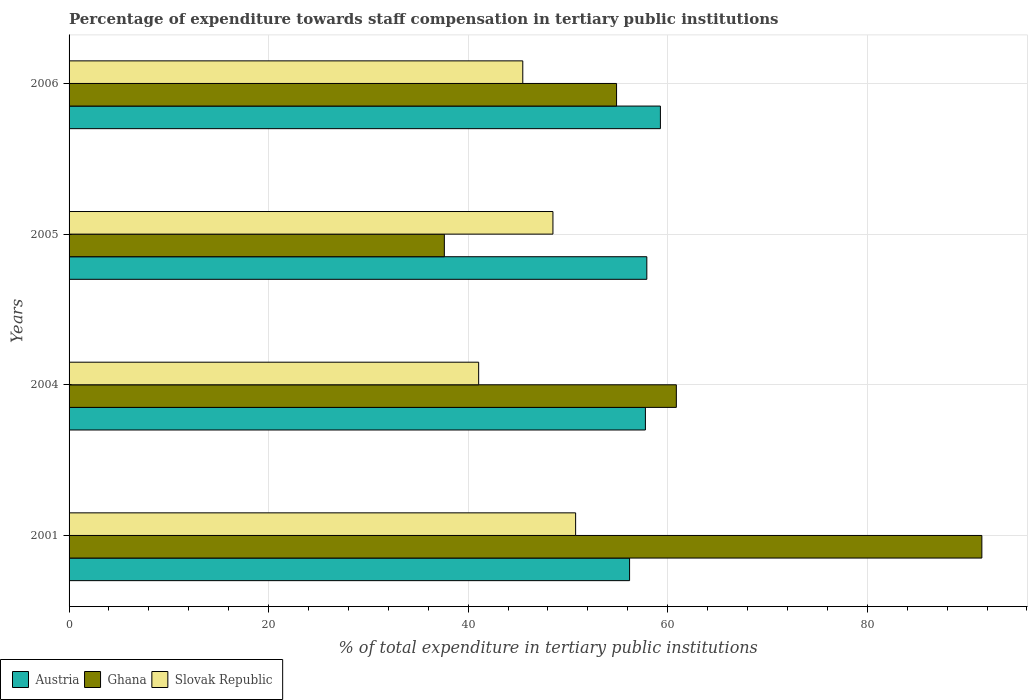Are the number of bars on each tick of the Y-axis equal?
Provide a succinct answer. Yes. How many bars are there on the 4th tick from the bottom?
Your answer should be very brief. 3. What is the label of the 4th group of bars from the top?
Your answer should be compact. 2001. In how many cases, is the number of bars for a given year not equal to the number of legend labels?
Keep it short and to the point. 0. What is the percentage of expenditure towards staff compensation in Slovak Republic in 2006?
Offer a very short reply. 45.47. Across all years, what is the maximum percentage of expenditure towards staff compensation in Slovak Republic?
Your answer should be very brief. 50.77. Across all years, what is the minimum percentage of expenditure towards staff compensation in Slovak Republic?
Offer a very short reply. 41.05. What is the total percentage of expenditure towards staff compensation in Austria in the graph?
Give a very brief answer. 231.11. What is the difference between the percentage of expenditure towards staff compensation in Slovak Republic in 2004 and that in 2005?
Your answer should be compact. -7.45. What is the difference between the percentage of expenditure towards staff compensation in Slovak Republic in 2004 and the percentage of expenditure towards staff compensation in Austria in 2006?
Give a very brief answer. -18.22. What is the average percentage of expenditure towards staff compensation in Slovak Republic per year?
Provide a short and direct response. 46.45. In the year 2006, what is the difference between the percentage of expenditure towards staff compensation in Austria and percentage of expenditure towards staff compensation in Slovak Republic?
Make the answer very short. 13.79. What is the ratio of the percentage of expenditure towards staff compensation in Austria in 2004 to that in 2005?
Ensure brevity in your answer.  1. Is the percentage of expenditure towards staff compensation in Austria in 2001 less than that in 2004?
Your answer should be very brief. Yes. Is the difference between the percentage of expenditure towards staff compensation in Austria in 2004 and 2005 greater than the difference between the percentage of expenditure towards staff compensation in Slovak Republic in 2004 and 2005?
Your answer should be very brief. Yes. What is the difference between the highest and the second highest percentage of expenditure towards staff compensation in Ghana?
Offer a very short reply. 30.62. What is the difference between the highest and the lowest percentage of expenditure towards staff compensation in Slovak Republic?
Keep it short and to the point. 9.72. In how many years, is the percentage of expenditure towards staff compensation in Ghana greater than the average percentage of expenditure towards staff compensation in Ghana taken over all years?
Offer a terse response. 1. What does the 1st bar from the bottom in 2005 represents?
Provide a succinct answer. Austria. Is it the case that in every year, the sum of the percentage of expenditure towards staff compensation in Slovak Republic and percentage of expenditure towards staff compensation in Austria is greater than the percentage of expenditure towards staff compensation in Ghana?
Keep it short and to the point. Yes. Are all the bars in the graph horizontal?
Provide a short and direct response. Yes. Are the values on the major ticks of X-axis written in scientific E-notation?
Make the answer very short. No. How many legend labels are there?
Provide a succinct answer. 3. What is the title of the graph?
Ensure brevity in your answer.  Percentage of expenditure towards staff compensation in tertiary public institutions. What is the label or title of the X-axis?
Offer a terse response. % of total expenditure in tertiary public institutions. What is the % of total expenditure in tertiary public institutions in Austria in 2001?
Offer a very short reply. 56.18. What is the % of total expenditure in tertiary public institutions of Ghana in 2001?
Offer a very short reply. 91.48. What is the % of total expenditure in tertiary public institutions in Slovak Republic in 2001?
Offer a terse response. 50.77. What is the % of total expenditure in tertiary public institutions in Austria in 2004?
Offer a terse response. 57.76. What is the % of total expenditure in tertiary public institutions in Ghana in 2004?
Offer a very short reply. 60.86. What is the % of total expenditure in tertiary public institutions of Slovak Republic in 2004?
Provide a succinct answer. 41.05. What is the % of total expenditure in tertiary public institutions in Austria in 2005?
Ensure brevity in your answer.  57.91. What is the % of total expenditure in tertiary public institutions of Ghana in 2005?
Your response must be concise. 37.61. What is the % of total expenditure in tertiary public institutions in Slovak Republic in 2005?
Your answer should be very brief. 48.5. What is the % of total expenditure in tertiary public institutions of Austria in 2006?
Keep it short and to the point. 59.27. What is the % of total expenditure in tertiary public institutions of Ghana in 2006?
Your response must be concise. 54.87. What is the % of total expenditure in tertiary public institutions of Slovak Republic in 2006?
Your response must be concise. 45.47. Across all years, what is the maximum % of total expenditure in tertiary public institutions of Austria?
Offer a terse response. 59.27. Across all years, what is the maximum % of total expenditure in tertiary public institutions in Ghana?
Provide a succinct answer. 91.48. Across all years, what is the maximum % of total expenditure in tertiary public institutions of Slovak Republic?
Your answer should be very brief. 50.77. Across all years, what is the minimum % of total expenditure in tertiary public institutions in Austria?
Your answer should be compact. 56.18. Across all years, what is the minimum % of total expenditure in tertiary public institutions in Ghana?
Your answer should be very brief. 37.61. Across all years, what is the minimum % of total expenditure in tertiary public institutions in Slovak Republic?
Give a very brief answer. 41.05. What is the total % of total expenditure in tertiary public institutions of Austria in the graph?
Give a very brief answer. 231.11. What is the total % of total expenditure in tertiary public institutions of Ghana in the graph?
Offer a very short reply. 244.83. What is the total % of total expenditure in tertiary public institutions of Slovak Republic in the graph?
Ensure brevity in your answer.  185.79. What is the difference between the % of total expenditure in tertiary public institutions of Austria in 2001 and that in 2004?
Keep it short and to the point. -1.59. What is the difference between the % of total expenditure in tertiary public institutions in Ghana in 2001 and that in 2004?
Your answer should be compact. 30.62. What is the difference between the % of total expenditure in tertiary public institutions in Slovak Republic in 2001 and that in 2004?
Provide a succinct answer. 9.72. What is the difference between the % of total expenditure in tertiary public institutions in Austria in 2001 and that in 2005?
Offer a very short reply. -1.73. What is the difference between the % of total expenditure in tertiary public institutions in Ghana in 2001 and that in 2005?
Give a very brief answer. 53.87. What is the difference between the % of total expenditure in tertiary public institutions in Slovak Republic in 2001 and that in 2005?
Provide a short and direct response. 2.27. What is the difference between the % of total expenditure in tertiary public institutions in Austria in 2001 and that in 2006?
Give a very brief answer. -3.09. What is the difference between the % of total expenditure in tertiary public institutions of Ghana in 2001 and that in 2006?
Your answer should be compact. 36.61. What is the difference between the % of total expenditure in tertiary public institutions in Slovak Republic in 2001 and that in 2006?
Ensure brevity in your answer.  5.3. What is the difference between the % of total expenditure in tertiary public institutions in Austria in 2004 and that in 2005?
Your answer should be very brief. -0.14. What is the difference between the % of total expenditure in tertiary public institutions in Ghana in 2004 and that in 2005?
Offer a very short reply. 23.25. What is the difference between the % of total expenditure in tertiary public institutions of Slovak Republic in 2004 and that in 2005?
Offer a terse response. -7.45. What is the difference between the % of total expenditure in tertiary public institutions in Austria in 2004 and that in 2006?
Offer a very short reply. -1.5. What is the difference between the % of total expenditure in tertiary public institutions of Ghana in 2004 and that in 2006?
Provide a short and direct response. 5.99. What is the difference between the % of total expenditure in tertiary public institutions of Slovak Republic in 2004 and that in 2006?
Offer a terse response. -4.42. What is the difference between the % of total expenditure in tertiary public institutions of Austria in 2005 and that in 2006?
Ensure brevity in your answer.  -1.36. What is the difference between the % of total expenditure in tertiary public institutions in Ghana in 2005 and that in 2006?
Offer a very short reply. -17.26. What is the difference between the % of total expenditure in tertiary public institutions of Slovak Republic in 2005 and that in 2006?
Your response must be concise. 3.02. What is the difference between the % of total expenditure in tertiary public institutions in Austria in 2001 and the % of total expenditure in tertiary public institutions in Ghana in 2004?
Provide a succinct answer. -4.69. What is the difference between the % of total expenditure in tertiary public institutions of Austria in 2001 and the % of total expenditure in tertiary public institutions of Slovak Republic in 2004?
Make the answer very short. 15.13. What is the difference between the % of total expenditure in tertiary public institutions of Ghana in 2001 and the % of total expenditure in tertiary public institutions of Slovak Republic in 2004?
Your answer should be very brief. 50.43. What is the difference between the % of total expenditure in tertiary public institutions of Austria in 2001 and the % of total expenditure in tertiary public institutions of Ghana in 2005?
Give a very brief answer. 18.57. What is the difference between the % of total expenditure in tertiary public institutions in Austria in 2001 and the % of total expenditure in tertiary public institutions in Slovak Republic in 2005?
Offer a terse response. 7.68. What is the difference between the % of total expenditure in tertiary public institutions in Ghana in 2001 and the % of total expenditure in tertiary public institutions in Slovak Republic in 2005?
Give a very brief answer. 42.99. What is the difference between the % of total expenditure in tertiary public institutions in Austria in 2001 and the % of total expenditure in tertiary public institutions in Ghana in 2006?
Your answer should be compact. 1.3. What is the difference between the % of total expenditure in tertiary public institutions of Austria in 2001 and the % of total expenditure in tertiary public institutions of Slovak Republic in 2006?
Offer a terse response. 10.7. What is the difference between the % of total expenditure in tertiary public institutions in Ghana in 2001 and the % of total expenditure in tertiary public institutions in Slovak Republic in 2006?
Provide a short and direct response. 46.01. What is the difference between the % of total expenditure in tertiary public institutions in Austria in 2004 and the % of total expenditure in tertiary public institutions in Ghana in 2005?
Ensure brevity in your answer.  20.15. What is the difference between the % of total expenditure in tertiary public institutions in Austria in 2004 and the % of total expenditure in tertiary public institutions in Slovak Republic in 2005?
Offer a very short reply. 9.27. What is the difference between the % of total expenditure in tertiary public institutions of Ghana in 2004 and the % of total expenditure in tertiary public institutions of Slovak Republic in 2005?
Ensure brevity in your answer.  12.37. What is the difference between the % of total expenditure in tertiary public institutions in Austria in 2004 and the % of total expenditure in tertiary public institutions in Ghana in 2006?
Your answer should be very brief. 2.89. What is the difference between the % of total expenditure in tertiary public institutions of Austria in 2004 and the % of total expenditure in tertiary public institutions of Slovak Republic in 2006?
Your answer should be compact. 12.29. What is the difference between the % of total expenditure in tertiary public institutions in Ghana in 2004 and the % of total expenditure in tertiary public institutions in Slovak Republic in 2006?
Your answer should be compact. 15.39. What is the difference between the % of total expenditure in tertiary public institutions in Austria in 2005 and the % of total expenditure in tertiary public institutions in Ghana in 2006?
Your response must be concise. 3.03. What is the difference between the % of total expenditure in tertiary public institutions of Austria in 2005 and the % of total expenditure in tertiary public institutions of Slovak Republic in 2006?
Ensure brevity in your answer.  12.43. What is the difference between the % of total expenditure in tertiary public institutions of Ghana in 2005 and the % of total expenditure in tertiary public institutions of Slovak Republic in 2006?
Provide a succinct answer. -7.86. What is the average % of total expenditure in tertiary public institutions of Austria per year?
Your response must be concise. 57.78. What is the average % of total expenditure in tertiary public institutions in Ghana per year?
Ensure brevity in your answer.  61.21. What is the average % of total expenditure in tertiary public institutions in Slovak Republic per year?
Ensure brevity in your answer.  46.45. In the year 2001, what is the difference between the % of total expenditure in tertiary public institutions in Austria and % of total expenditure in tertiary public institutions in Ghana?
Offer a very short reply. -35.31. In the year 2001, what is the difference between the % of total expenditure in tertiary public institutions in Austria and % of total expenditure in tertiary public institutions in Slovak Republic?
Your answer should be very brief. 5.41. In the year 2001, what is the difference between the % of total expenditure in tertiary public institutions in Ghana and % of total expenditure in tertiary public institutions in Slovak Republic?
Keep it short and to the point. 40.71. In the year 2004, what is the difference between the % of total expenditure in tertiary public institutions of Austria and % of total expenditure in tertiary public institutions of Ghana?
Offer a very short reply. -3.1. In the year 2004, what is the difference between the % of total expenditure in tertiary public institutions of Austria and % of total expenditure in tertiary public institutions of Slovak Republic?
Offer a terse response. 16.71. In the year 2004, what is the difference between the % of total expenditure in tertiary public institutions in Ghana and % of total expenditure in tertiary public institutions in Slovak Republic?
Your answer should be very brief. 19.81. In the year 2005, what is the difference between the % of total expenditure in tertiary public institutions in Austria and % of total expenditure in tertiary public institutions in Ghana?
Offer a terse response. 20.3. In the year 2005, what is the difference between the % of total expenditure in tertiary public institutions of Austria and % of total expenditure in tertiary public institutions of Slovak Republic?
Provide a short and direct response. 9.41. In the year 2005, what is the difference between the % of total expenditure in tertiary public institutions of Ghana and % of total expenditure in tertiary public institutions of Slovak Republic?
Your response must be concise. -10.88. In the year 2006, what is the difference between the % of total expenditure in tertiary public institutions in Austria and % of total expenditure in tertiary public institutions in Ghana?
Give a very brief answer. 4.39. In the year 2006, what is the difference between the % of total expenditure in tertiary public institutions in Austria and % of total expenditure in tertiary public institutions in Slovak Republic?
Your answer should be very brief. 13.79. In the year 2006, what is the difference between the % of total expenditure in tertiary public institutions of Ghana and % of total expenditure in tertiary public institutions of Slovak Republic?
Keep it short and to the point. 9.4. What is the ratio of the % of total expenditure in tertiary public institutions of Austria in 2001 to that in 2004?
Provide a short and direct response. 0.97. What is the ratio of the % of total expenditure in tertiary public institutions in Ghana in 2001 to that in 2004?
Offer a terse response. 1.5. What is the ratio of the % of total expenditure in tertiary public institutions of Slovak Republic in 2001 to that in 2004?
Keep it short and to the point. 1.24. What is the ratio of the % of total expenditure in tertiary public institutions in Austria in 2001 to that in 2005?
Offer a very short reply. 0.97. What is the ratio of the % of total expenditure in tertiary public institutions of Ghana in 2001 to that in 2005?
Provide a succinct answer. 2.43. What is the ratio of the % of total expenditure in tertiary public institutions of Slovak Republic in 2001 to that in 2005?
Provide a short and direct response. 1.05. What is the ratio of the % of total expenditure in tertiary public institutions in Austria in 2001 to that in 2006?
Provide a succinct answer. 0.95. What is the ratio of the % of total expenditure in tertiary public institutions in Ghana in 2001 to that in 2006?
Your response must be concise. 1.67. What is the ratio of the % of total expenditure in tertiary public institutions in Slovak Republic in 2001 to that in 2006?
Your response must be concise. 1.12. What is the ratio of the % of total expenditure in tertiary public institutions of Ghana in 2004 to that in 2005?
Your answer should be very brief. 1.62. What is the ratio of the % of total expenditure in tertiary public institutions in Slovak Republic in 2004 to that in 2005?
Ensure brevity in your answer.  0.85. What is the ratio of the % of total expenditure in tertiary public institutions in Austria in 2004 to that in 2006?
Your response must be concise. 0.97. What is the ratio of the % of total expenditure in tertiary public institutions in Ghana in 2004 to that in 2006?
Make the answer very short. 1.11. What is the ratio of the % of total expenditure in tertiary public institutions of Slovak Republic in 2004 to that in 2006?
Make the answer very short. 0.9. What is the ratio of the % of total expenditure in tertiary public institutions in Ghana in 2005 to that in 2006?
Offer a very short reply. 0.69. What is the ratio of the % of total expenditure in tertiary public institutions in Slovak Republic in 2005 to that in 2006?
Your response must be concise. 1.07. What is the difference between the highest and the second highest % of total expenditure in tertiary public institutions of Austria?
Offer a terse response. 1.36. What is the difference between the highest and the second highest % of total expenditure in tertiary public institutions of Ghana?
Provide a short and direct response. 30.62. What is the difference between the highest and the second highest % of total expenditure in tertiary public institutions of Slovak Republic?
Offer a very short reply. 2.27. What is the difference between the highest and the lowest % of total expenditure in tertiary public institutions in Austria?
Your answer should be compact. 3.09. What is the difference between the highest and the lowest % of total expenditure in tertiary public institutions in Ghana?
Give a very brief answer. 53.87. What is the difference between the highest and the lowest % of total expenditure in tertiary public institutions in Slovak Republic?
Your response must be concise. 9.72. 